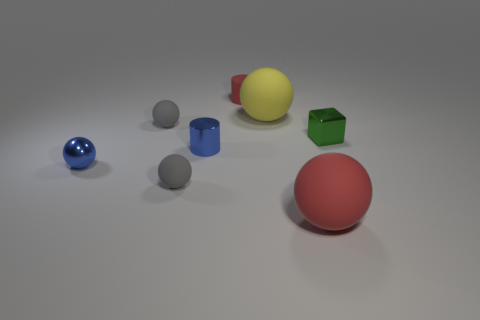Subtract all yellow spheres. How many spheres are left? 4 Subtract all red spheres. How many spheres are left? 4 Add 1 yellow rubber objects. How many objects exist? 9 Subtract all cubes. How many objects are left? 7 Subtract all red blocks. Subtract all gray cylinders. How many blocks are left? 1 Subtract all green cylinders. How many purple cubes are left? 0 Subtract all tiny purple rubber cylinders. Subtract all big yellow matte things. How many objects are left? 7 Add 2 small gray things. How many small gray things are left? 4 Add 6 blue cylinders. How many blue cylinders exist? 7 Subtract 1 blue cylinders. How many objects are left? 7 